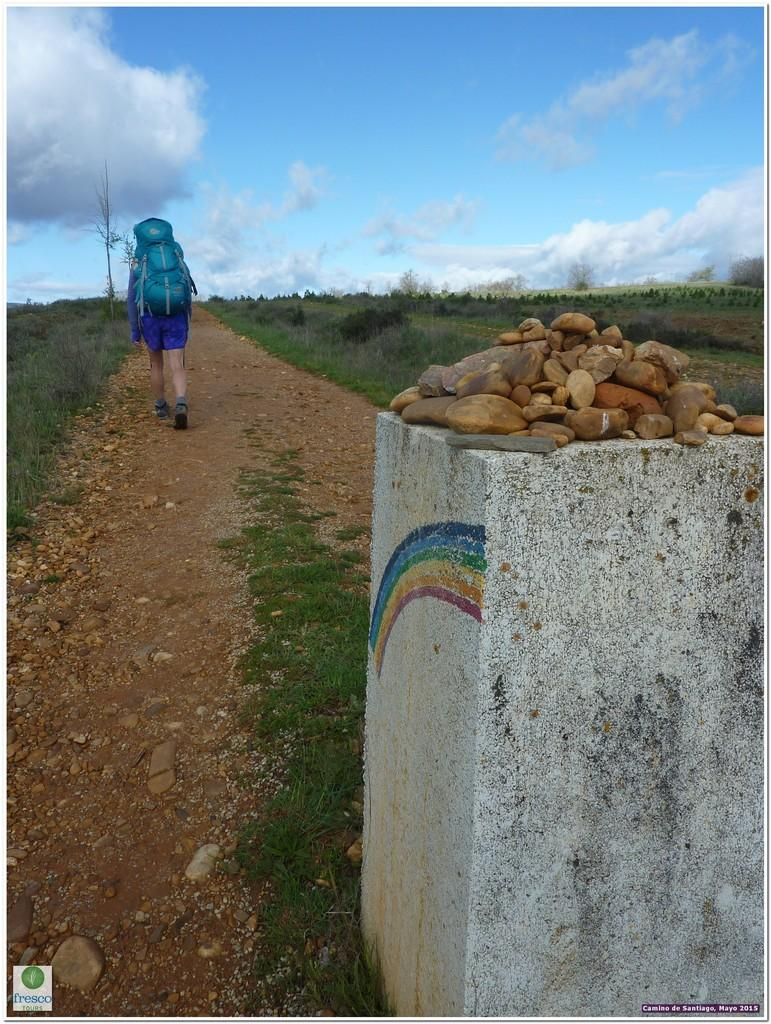Who is present in the image? There is a man in the image. What is the man wearing? The man is wearing a bag. What type of terrain is visible in the image? There is grass and stones in the image. What is visible in the background of the image? The sky is visible in the image, and clouds are present in the sky. What type of rings can be seen on the man's fingers in the image? There are no rings visible on the man's fingers in the image. What is the man using to control the clouds in the sky? The man is not controlling the clouds in the image, and there is no indication of any control device. 